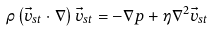Convert formula to latex. <formula><loc_0><loc_0><loc_500><loc_500>\rho \left ( \vec { v } _ { s t } \cdot \nabla \right ) \vec { v } _ { s t } = - \nabla p + \eta \nabla ^ { 2 } \vec { v } _ { s t }</formula> 